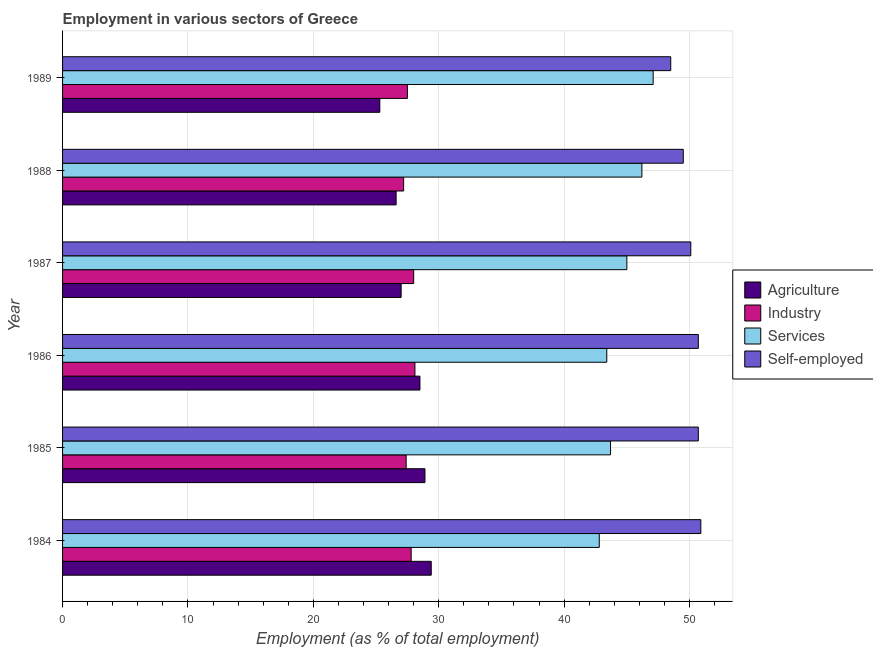How many different coloured bars are there?
Provide a succinct answer. 4. How many groups of bars are there?
Your response must be concise. 6. Are the number of bars per tick equal to the number of legend labels?
Offer a very short reply. Yes. Are the number of bars on each tick of the Y-axis equal?
Your answer should be compact. Yes. How many bars are there on the 6th tick from the top?
Offer a terse response. 4. How many bars are there on the 6th tick from the bottom?
Ensure brevity in your answer.  4. In how many cases, is the number of bars for a given year not equal to the number of legend labels?
Make the answer very short. 0. What is the percentage of workers in services in 1989?
Keep it short and to the point. 47.1. Across all years, what is the maximum percentage of workers in industry?
Make the answer very short. 28.1. Across all years, what is the minimum percentage of workers in agriculture?
Ensure brevity in your answer.  25.3. In which year was the percentage of workers in industry maximum?
Offer a terse response. 1986. In which year was the percentage of workers in industry minimum?
Ensure brevity in your answer.  1988. What is the total percentage of self employed workers in the graph?
Give a very brief answer. 300.4. What is the difference between the percentage of workers in industry in 1984 and that in 1986?
Give a very brief answer. -0.3. What is the difference between the percentage of workers in agriculture in 1988 and the percentage of self employed workers in 1984?
Ensure brevity in your answer.  -24.3. What is the average percentage of workers in services per year?
Provide a short and direct response. 44.7. In the year 1987, what is the difference between the percentage of workers in agriculture and percentage of self employed workers?
Your answer should be compact. -23.1. In how many years, is the percentage of workers in agriculture greater than 34 %?
Give a very brief answer. 0. Is the percentage of self employed workers in 1984 less than that in 1987?
Make the answer very short. No. Is the difference between the percentage of self employed workers in 1985 and 1986 greater than the difference between the percentage of workers in industry in 1985 and 1986?
Your answer should be compact. Yes. What is the difference between the highest and the second highest percentage of workers in industry?
Make the answer very short. 0.1. Is it the case that in every year, the sum of the percentage of workers in industry and percentage of self employed workers is greater than the sum of percentage of workers in services and percentage of workers in agriculture?
Your response must be concise. Yes. What does the 1st bar from the top in 1989 represents?
Offer a very short reply. Self-employed. What does the 1st bar from the bottom in 1984 represents?
Offer a terse response. Agriculture. Is it the case that in every year, the sum of the percentage of workers in agriculture and percentage of workers in industry is greater than the percentage of workers in services?
Provide a short and direct response. Yes. How many bars are there?
Your answer should be compact. 24. Are all the bars in the graph horizontal?
Offer a terse response. Yes. What is the difference between two consecutive major ticks on the X-axis?
Make the answer very short. 10. Are the values on the major ticks of X-axis written in scientific E-notation?
Your answer should be compact. No. Does the graph contain any zero values?
Make the answer very short. No. How many legend labels are there?
Offer a terse response. 4. How are the legend labels stacked?
Keep it short and to the point. Vertical. What is the title of the graph?
Keep it short and to the point. Employment in various sectors of Greece. Does "Trade" appear as one of the legend labels in the graph?
Your answer should be very brief. No. What is the label or title of the X-axis?
Make the answer very short. Employment (as % of total employment). What is the label or title of the Y-axis?
Your answer should be compact. Year. What is the Employment (as % of total employment) of Agriculture in 1984?
Give a very brief answer. 29.4. What is the Employment (as % of total employment) of Industry in 1984?
Make the answer very short. 27.8. What is the Employment (as % of total employment) of Services in 1984?
Offer a very short reply. 42.8. What is the Employment (as % of total employment) of Self-employed in 1984?
Give a very brief answer. 50.9. What is the Employment (as % of total employment) of Agriculture in 1985?
Ensure brevity in your answer.  28.9. What is the Employment (as % of total employment) in Industry in 1985?
Ensure brevity in your answer.  27.4. What is the Employment (as % of total employment) of Services in 1985?
Your response must be concise. 43.7. What is the Employment (as % of total employment) of Self-employed in 1985?
Offer a very short reply. 50.7. What is the Employment (as % of total employment) in Industry in 1986?
Make the answer very short. 28.1. What is the Employment (as % of total employment) in Services in 1986?
Offer a terse response. 43.4. What is the Employment (as % of total employment) of Self-employed in 1986?
Your answer should be compact. 50.7. What is the Employment (as % of total employment) in Agriculture in 1987?
Your answer should be very brief. 27. What is the Employment (as % of total employment) in Services in 1987?
Provide a short and direct response. 45. What is the Employment (as % of total employment) of Self-employed in 1987?
Your answer should be compact. 50.1. What is the Employment (as % of total employment) of Agriculture in 1988?
Provide a short and direct response. 26.6. What is the Employment (as % of total employment) of Industry in 1988?
Offer a terse response. 27.2. What is the Employment (as % of total employment) of Services in 1988?
Give a very brief answer. 46.2. What is the Employment (as % of total employment) of Self-employed in 1988?
Offer a terse response. 49.5. What is the Employment (as % of total employment) of Agriculture in 1989?
Offer a very short reply. 25.3. What is the Employment (as % of total employment) in Industry in 1989?
Your answer should be compact. 27.5. What is the Employment (as % of total employment) in Services in 1989?
Ensure brevity in your answer.  47.1. What is the Employment (as % of total employment) in Self-employed in 1989?
Offer a terse response. 48.5. Across all years, what is the maximum Employment (as % of total employment) in Agriculture?
Provide a succinct answer. 29.4. Across all years, what is the maximum Employment (as % of total employment) in Industry?
Provide a succinct answer. 28.1. Across all years, what is the maximum Employment (as % of total employment) in Services?
Keep it short and to the point. 47.1. Across all years, what is the maximum Employment (as % of total employment) in Self-employed?
Keep it short and to the point. 50.9. Across all years, what is the minimum Employment (as % of total employment) in Agriculture?
Your answer should be very brief. 25.3. Across all years, what is the minimum Employment (as % of total employment) of Industry?
Your response must be concise. 27.2. Across all years, what is the minimum Employment (as % of total employment) of Services?
Keep it short and to the point. 42.8. Across all years, what is the minimum Employment (as % of total employment) in Self-employed?
Your answer should be compact. 48.5. What is the total Employment (as % of total employment) of Agriculture in the graph?
Make the answer very short. 165.7. What is the total Employment (as % of total employment) in Industry in the graph?
Offer a terse response. 166. What is the total Employment (as % of total employment) of Services in the graph?
Offer a very short reply. 268.2. What is the total Employment (as % of total employment) in Self-employed in the graph?
Your answer should be very brief. 300.4. What is the difference between the Employment (as % of total employment) in Self-employed in 1984 and that in 1985?
Make the answer very short. 0.2. What is the difference between the Employment (as % of total employment) of Agriculture in 1984 and that in 1986?
Your response must be concise. 0.9. What is the difference between the Employment (as % of total employment) of Industry in 1984 and that in 1986?
Keep it short and to the point. -0.3. What is the difference between the Employment (as % of total employment) of Self-employed in 1984 and that in 1987?
Offer a terse response. 0.8. What is the difference between the Employment (as % of total employment) of Industry in 1984 and that in 1988?
Offer a very short reply. 0.6. What is the difference between the Employment (as % of total employment) of Services in 1984 and that in 1988?
Make the answer very short. -3.4. What is the difference between the Employment (as % of total employment) of Industry in 1984 and that in 1989?
Your answer should be compact. 0.3. What is the difference between the Employment (as % of total employment) of Self-employed in 1984 and that in 1989?
Offer a very short reply. 2.4. What is the difference between the Employment (as % of total employment) of Agriculture in 1985 and that in 1986?
Offer a very short reply. 0.4. What is the difference between the Employment (as % of total employment) in Services in 1985 and that in 1986?
Ensure brevity in your answer.  0.3. What is the difference between the Employment (as % of total employment) in Self-employed in 1985 and that in 1986?
Your answer should be compact. 0. What is the difference between the Employment (as % of total employment) of Industry in 1985 and that in 1987?
Give a very brief answer. -0.6. What is the difference between the Employment (as % of total employment) of Self-employed in 1985 and that in 1987?
Give a very brief answer. 0.6. What is the difference between the Employment (as % of total employment) in Agriculture in 1985 and that in 1989?
Make the answer very short. 3.6. What is the difference between the Employment (as % of total employment) in Services in 1985 and that in 1989?
Offer a terse response. -3.4. What is the difference between the Employment (as % of total employment) of Self-employed in 1985 and that in 1989?
Give a very brief answer. 2.2. What is the difference between the Employment (as % of total employment) in Agriculture in 1986 and that in 1987?
Offer a very short reply. 1.5. What is the difference between the Employment (as % of total employment) of Industry in 1986 and that in 1987?
Offer a very short reply. 0.1. What is the difference between the Employment (as % of total employment) in Services in 1986 and that in 1987?
Provide a short and direct response. -1.6. What is the difference between the Employment (as % of total employment) in Self-employed in 1986 and that in 1987?
Offer a very short reply. 0.6. What is the difference between the Employment (as % of total employment) of Agriculture in 1986 and that in 1988?
Offer a terse response. 1.9. What is the difference between the Employment (as % of total employment) in Self-employed in 1986 and that in 1988?
Ensure brevity in your answer.  1.2. What is the difference between the Employment (as % of total employment) of Agriculture in 1986 and that in 1989?
Your answer should be very brief. 3.2. What is the difference between the Employment (as % of total employment) in Industry in 1986 and that in 1989?
Offer a terse response. 0.6. What is the difference between the Employment (as % of total employment) in Services in 1986 and that in 1989?
Give a very brief answer. -3.7. What is the difference between the Employment (as % of total employment) of Self-employed in 1986 and that in 1989?
Provide a short and direct response. 2.2. What is the difference between the Employment (as % of total employment) in Agriculture in 1987 and that in 1988?
Your answer should be very brief. 0.4. What is the difference between the Employment (as % of total employment) in Self-employed in 1987 and that in 1988?
Give a very brief answer. 0.6. What is the difference between the Employment (as % of total employment) in Industry in 1988 and that in 1989?
Make the answer very short. -0.3. What is the difference between the Employment (as % of total employment) of Agriculture in 1984 and the Employment (as % of total employment) of Industry in 1985?
Make the answer very short. 2. What is the difference between the Employment (as % of total employment) of Agriculture in 1984 and the Employment (as % of total employment) of Services in 1985?
Provide a succinct answer. -14.3. What is the difference between the Employment (as % of total employment) in Agriculture in 1984 and the Employment (as % of total employment) in Self-employed in 1985?
Your answer should be very brief. -21.3. What is the difference between the Employment (as % of total employment) in Industry in 1984 and the Employment (as % of total employment) in Services in 1985?
Your answer should be very brief. -15.9. What is the difference between the Employment (as % of total employment) in Industry in 1984 and the Employment (as % of total employment) in Self-employed in 1985?
Make the answer very short. -22.9. What is the difference between the Employment (as % of total employment) in Services in 1984 and the Employment (as % of total employment) in Self-employed in 1985?
Give a very brief answer. -7.9. What is the difference between the Employment (as % of total employment) of Agriculture in 1984 and the Employment (as % of total employment) of Services in 1986?
Your answer should be very brief. -14. What is the difference between the Employment (as % of total employment) of Agriculture in 1984 and the Employment (as % of total employment) of Self-employed in 1986?
Give a very brief answer. -21.3. What is the difference between the Employment (as % of total employment) of Industry in 1984 and the Employment (as % of total employment) of Services in 1986?
Your answer should be very brief. -15.6. What is the difference between the Employment (as % of total employment) in Industry in 1984 and the Employment (as % of total employment) in Self-employed in 1986?
Give a very brief answer. -22.9. What is the difference between the Employment (as % of total employment) of Agriculture in 1984 and the Employment (as % of total employment) of Services in 1987?
Give a very brief answer. -15.6. What is the difference between the Employment (as % of total employment) in Agriculture in 1984 and the Employment (as % of total employment) in Self-employed in 1987?
Make the answer very short. -20.7. What is the difference between the Employment (as % of total employment) in Industry in 1984 and the Employment (as % of total employment) in Services in 1987?
Give a very brief answer. -17.2. What is the difference between the Employment (as % of total employment) in Industry in 1984 and the Employment (as % of total employment) in Self-employed in 1987?
Your answer should be compact. -22.3. What is the difference between the Employment (as % of total employment) of Agriculture in 1984 and the Employment (as % of total employment) of Industry in 1988?
Your answer should be compact. 2.2. What is the difference between the Employment (as % of total employment) in Agriculture in 1984 and the Employment (as % of total employment) in Services in 1988?
Offer a very short reply. -16.8. What is the difference between the Employment (as % of total employment) in Agriculture in 1984 and the Employment (as % of total employment) in Self-employed in 1988?
Your answer should be compact. -20.1. What is the difference between the Employment (as % of total employment) in Industry in 1984 and the Employment (as % of total employment) in Services in 1988?
Give a very brief answer. -18.4. What is the difference between the Employment (as % of total employment) of Industry in 1984 and the Employment (as % of total employment) of Self-employed in 1988?
Your response must be concise. -21.7. What is the difference between the Employment (as % of total employment) of Agriculture in 1984 and the Employment (as % of total employment) of Industry in 1989?
Provide a succinct answer. 1.9. What is the difference between the Employment (as % of total employment) in Agriculture in 1984 and the Employment (as % of total employment) in Services in 1989?
Make the answer very short. -17.7. What is the difference between the Employment (as % of total employment) of Agriculture in 1984 and the Employment (as % of total employment) of Self-employed in 1989?
Your answer should be very brief. -19.1. What is the difference between the Employment (as % of total employment) in Industry in 1984 and the Employment (as % of total employment) in Services in 1989?
Give a very brief answer. -19.3. What is the difference between the Employment (as % of total employment) in Industry in 1984 and the Employment (as % of total employment) in Self-employed in 1989?
Your answer should be very brief. -20.7. What is the difference between the Employment (as % of total employment) of Services in 1984 and the Employment (as % of total employment) of Self-employed in 1989?
Make the answer very short. -5.7. What is the difference between the Employment (as % of total employment) of Agriculture in 1985 and the Employment (as % of total employment) of Self-employed in 1986?
Your answer should be very brief. -21.8. What is the difference between the Employment (as % of total employment) of Industry in 1985 and the Employment (as % of total employment) of Services in 1986?
Give a very brief answer. -16. What is the difference between the Employment (as % of total employment) in Industry in 1985 and the Employment (as % of total employment) in Self-employed in 1986?
Ensure brevity in your answer.  -23.3. What is the difference between the Employment (as % of total employment) of Services in 1985 and the Employment (as % of total employment) of Self-employed in 1986?
Offer a very short reply. -7. What is the difference between the Employment (as % of total employment) of Agriculture in 1985 and the Employment (as % of total employment) of Industry in 1987?
Offer a very short reply. 0.9. What is the difference between the Employment (as % of total employment) of Agriculture in 1985 and the Employment (as % of total employment) of Services in 1987?
Provide a short and direct response. -16.1. What is the difference between the Employment (as % of total employment) of Agriculture in 1985 and the Employment (as % of total employment) of Self-employed in 1987?
Make the answer very short. -21.2. What is the difference between the Employment (as % of total employment) in Industry in 1985 and the Employment (as % of total employment) in Services in 1987?
Make the answer very short. -17.6. What is the difference between the Employment (as % of total employment) of Industry in 1985 and the Employment (as % of total employment) of Self-employed in 1987?
Give a very brief answer. -22.7. What is the difference between the Employment (as % of total employment) in Services in 1985 and the Employment (as % of total employment) in Self-employed in 1987?
Offer a very short reply. -6.4. What is the difference between the Employment (as % of total employment) of Agriculture in 1985 and the Employment (as % of total employment) of Services in 1988?
Ensure brevity in your answer.  -17.3. What is the difference between the Employment (as % of total employment) of Agriculture in 1985 and the Employment (as % of total employment) of Self-employed in 1988?
Your response must be concise. -20.6. What is the difference between the Employment (as % of total employment) of Industry in 1985 and the Employment (as % of total employment) of Services in 1988?
Your answer should be very brief. -18.8. What is the difference between the Employment (as % of total employment) of Industry in 1985 and the Employment (as % of total employment) of Self-employed in 1988?
Provide a short and direct response. -22.1. What is the difference between the Employment (as % of total employment) of Agriculture in 1985 and the Employment (as % of total employment) of Services in 1989?
Provide a short and direct response. -18.2. What is the difference between the Employment (as % of total employment) of Agriculture in 1985 and the Employment (as % of total employment) of Self-employed in 1989?
Keep it short and to the point. -19.6. What is the difference between the Employment (as % of total employment) of Industry in 1985 and the Employment (as % of total employment) of Services in 1989?
Provide a short and direct response. -19.7. What is the difference between the Employment (as % of total employment) of Industry in 1985 and the Employment (as % of total employment) of Self-employed in 1989?
Offer a terse response. -21.1. What is the difference between the Employment (as % of total employment) of Services in 1985 and the Employment (as % of total employment) of Self-employed in 1989?
Your answer should be compact. -4.8. What is the difference between the Employment (as % of total employment) of Agriculture in 1986 and the Employment (as % of total employment) of Industry in 1987?
Your answer should be very brief. 0.5. What is the difference between the Employment (as % of total employment) in Agriculture in 1986 and the Employment (as % of total employment) in Services in 1987?
Your response must be concise. -16.5. What is the difference between the Employment (as % of total employment) of Agriculture in 1986 and the Employment (as % of total employment) of Self-employed in 1987?
Ensure brevity in your answer.  -21.6. What is the difference between the Employment (as % of total employment) of Industry in 1986 and the Employment (as % of total employment) of Services in 1987?
Offer a very short reply. -16.9. What is the difference between the Employment (as % of total employment) of Services in 1986 and the Employment (as % of total employment) of Self-employed in 1987?
Make the answer very short. -6.7. What is the difference between the Employment (as % of total employment) in Agriculture in 1986 and the Employment (as % of total employment) in Industry in 1988?
Your response must be concise. 1.3. What is the difference between the Employment (as % of total employment) of Agriculture in 1986 and the Employment (as % of total employment) of Services in 1988?
Your answer should be compact. -17.7. What is the difference between the Employment (as % of total employment) of Industry in 1986 and the Employment (as % of total employment) of Services in 1988?
Offer a terse response. -18.1. What is the difference between the Employment (as % of total employment) of Industry in 1986 and the Employment (as % of total employment) of Self-employed in 1988?
Keep it short and to the point. -21.4. What is the difference between the Employment (as % of total employment) of Services in 1986 and the Employment (as % of total employment) of Self-employed in 1988?
Make the answer very short. -6.1. What is the difference between the Employment (as % of total employment) in Agriculture in 1986 and the Employment (as % of total employment) in Services in 1989?
Your answer should be very brief. -18.6. What is the difference between the Employment (as % of total employment) in Agriculture in 1986 and the Employment (as % of total employment) in Self-employed in 1989?
Offer a very short reply. -20. What is the difference between the Employment (as % of total employment) of Industry in 1986 and the Employment (as % of total employment) of Self-employed in 1989?
Keep it short and to the point. -20.4. What is the difference between the Employment (as % of total employment) of Services in 1986 and the Employment (as % of total employment) of Self-employed in 1989?
Offer a very short reply. -5.1. What is the difference between the Employment (as % of total employment) in Agriculture in 1987 and the Employment (as % of total employment) in Industry in 1988?
Make the answer very short. -0.2. What is the difference between the Employment (as % of total employment) of Agriculture in 1987 and the Employment (as % of total employment) of Services in 1988?
Offer a very short reply. -19.2. What is the difference between the Employment (as % of total employment) in Agriculture in 1987 and the Employment (as % of total employment) in Self-employed in 1988?
Provide a short and direct response. -22.5. What is the difference between the Employment (as % of total employment) of Industry in 1987 and the Employment (as % of total employment) of Services in 1988?
Ensure brevity in your answer.  -18.2. What is the difference between the Employment (as % of total employment) of Industry in 1987 and the Employment (as % of total employment) of Self-employed in 1988?
Provide a succinct answer. -21.5. What is the difference between the Employment (as % of total employment) of Agriculture in 1987 and the Employment (as % of total employment) of Services in 1989?
Keep it short and to the point. -20.1. What is the difference between the Employment (as % of total employment) of Agriculture in 1987 and the Employment (as % of total employment) of Self-employed in 1989?
Offer a terse response. -21.5. What is the difference between the Employment (as % of total employment) of Industry in 1987 and the Employment (as % of total employment) of Services in 1989?
Your answer should be very brief. -19.1. What is the difference between the Employment (as % of total employment) of Industry in 1987 and the Employment (as % of total employment) of Self-employed in 1989?
Offer a very short reply. -20.5. What is the difference between the Employment (as % of total employment) of Services in 1987 and the Employment (as % of total employment) of Self-employed in 1989?
Keep it short and to the point. -3.5. What is the difference between the Employment (as % of total employment) in Agriculture in 1988 and the Employment (as % of total employment) in Industry in 1989?
Offer a terse response. -0.9. What is the difference between the Employment (as % of total employment) in Agriculture in 1988 and the Employment (as % of total employment) in Services in 1989?
Give a very brief answer. -20.5. What is the difference between the Employment (as % of total employment) of Agriculture in 1988 and the Employment (as % of total employment) of Self-employed in 1989?
Offer a terse response. -21.9. What is the difference between the Employment (as % of total employment) of Industry in 1988 and the Employment (as % of total employment) of Services in 1989?
Provide a short and direct response. -19.9. What is the difference between the Employment (as % of total employment) in Industry in 1988 and the Employment (as % of total employment) in Self-employed in 1989?
Your response must be concise. -21.3. What is the average Employment (as % of total employment) in Agriculture per year?
Give a very brief answer. 27.62. What is the average Employment (as % of total employment) of Industry per year?
Offer a terse response. 27.67. What is the average Employment (as % of total employment) of Services per year?
Your answer should be very brief. 44.7. What is the average Employment (as % of total employment) in Self-employed per year?
Keep it short and to the point. 50.07. In the year 1984, what is the difference between the Employment (as % of total employment) in Agriculture and Employment (as % of total employment) in Industry?
Provide a succinct answer. 1.6. In the year 1984, what is the difference between the Employment (as % of total employment) of Agriculture and Employment (as % of total employment) of Self-employed?
Offer a terse response. -21.5. In the year 1984, what is the difference between the Employment (as % of total employment) of Industry and Employment (as % of total employment) of Self-employed?
Make the answer very short. -23.1. In the year 1984, what is the difference between the Employment (as % of total employment) in Services and Employment (as % of total employment) in Self-employed?
Ensure brevity in your answer.  -8.1. In the year 1985, what is the difference between the Employment (as % of total employment) in Agriculture and Employment (as % of total employment) in Services?
Your response must be concise. -14.8. In the year 1985, what is the difference between the Employment (as % of total employment) in Agriculture and Employment (as % of total employment) in Self-employed?
Provide a short and direct response. -21.8. In the year 1985, what is the difference between the Employment (as % of total employment) in Industry and Employment (as % of total employment) in Services?
Your answer should be compact. -16.3. In the year 1985, what is the difference between the Employment (as % of total employment) in Industry and Employment (as % of total employment) in Self-employed?
Your answer should be very brief. -23.3. In the year 1985, what is the difference between the Employment (as % of total employment) in Services and Employment (as % of total employment) in Self-employed?
Your answer should be compact. -7. In the year 1986, what is the difference between the Employment (as % of total employment) in Agriculture and Employment (as % of total employment) in Industry?
Provide a succinct answer. 0.4. In the year 1986, what is the difference between the Employment (as % of total employment) of Agriculture and Employment (as % of total employment) of Services?
Give a very brief answer. -14.9. In the year 1986, what is the difference between the Employment (as % of total employment) of Agriculture and Employment (as % of total employment) of Self-employed?
Offer a terse response. -22.2. In the year 1986, what is the difference between the Employment (as % of total employment) in Industry and Employment (as % of total employment) in Services?
Offer a very short reply. -15.3. In the year 1986, what is the difference between the Employment (as % of total employment) of Industry and Employment (as % of total employment) of Self-employed?
Your answer should be very brief. -22.6. In the year 1987, what is the difference between the Employment (as % of total employment) in Agriculture and Employment (as % of total employment) in Services?
Keep it short and to the point. -18. In the year 1987, what is the difference between the Employment (as % of total employment) in Agriculture and Employment (as % of total employment) in Self-employed?
Offer a terse response. -23.1. In the year 1987, what is the difference between the Employment (as % of total employment) of Industry and Employment (as % of total employment) of Self-employed?
Ensure brevity in your answer.  -22.1. In the year 1988, what is the difference between the Employment (as % of total employment) of Agriculture and Employment (as % of total employment) of Services?
Offer a terse response. -19.6. In the year 1988, what is the difference between the Employment (as % of total employment) of Agriculture and Employment (as % of total employment) of Self-employed?
Give a very brief answer. -22.9. In the year 1988, what is the difference between the Employment (as % of total employment) in Industry and Employment (as % of total employment) in Services?
Provide a short and direct response. -19. In the year 1988, what is the difference between the Employment (as % of total employment) in Industry and Employment (as % of total employment) in Self-employed?
Make the answer very short. -22.3. In the year 1988, what is the difference between the Employment (as % of total employment) of Services and Employment (as % of total employment) of Self-employed?
Make the answer very short. -3.3. In the year 1989, what is the difference between the Employment (as % of total employment) of Agriculture and Employment (as % of total employment) of Industry?
Give a very brief answer. -2.2. In the year 1989, what is the difference between the Employment (as % of total employment) in Agriculture and Employment (as % of total employment) in Services?
Your answer should be very brief. -21.8. In the year 1989, what is the difference between the Employment (as % of total employment) in Agriculture and Employment (as % of total employment) in Self-employed?
Ensure brevity in your answer.  -23.2. In the year 1989, what is the difference between the Employment (as % of total employment) in Industry and Employment (as % of total employment) in Services?
Your response must be concise. -19.6. In the year 1989, what is the difference between the Employment (as % of total employment) of Services and Employment (as % of total employment) of Self-employed?
Provide a succinct answer. -1.4. What is the ratio of the Employment (as % of total employment) of Agriculture in 1984 to that in 1985?
Your answer should be very brief. 1.02. What is the ratio of the Employment (as % of total employment) in Industry in 1984 to that in 1985?
Give a very brief answer. 1.01. What is the ratio of the Employment (as % of total employment) in Services in 1984 to that in 1985?
Offer a very short reply. 0.98. What is the ratio of the Employment (as % of total employment) in Self-employed in 1984 to that in 1985?
Provide a short and direct response. 1. What is the ratio of the Employment (as % of total employment) of Agriculture in 1984 to that in 1986?
Make the answer very short. 1.03. What is the ratio of the Employment (as % of total employment) of Industry in 1984 to that in 1986?
Ensure brevity in your answer.  0.99. What is the ratio of the Employment (as % of total employment) of Services in 1984 to that in 1986?
Provide a succinct answer. 0.99. What is the ratio of the Employment (as % of total employment) of Self-employed in 1984 to that in 1986?
Provide a short and direct response. 1. What is the ratio of the Employment (as % of total employment) of Agriculture in 1984 to that in 1987?
Offer a terse response. 1.09. What is the ratio of the Employment (as % of total employment) in Industry in 1984 to that in 1987?
Offer a very short reply. 0.99. What is the ratio of the Employment (as % of total employment) of Services in 1984 to that in 1987?
Provide a succinct answer. 0.95. What is the ratio of the Employment (as % of total employment) of Agriculture in 1984 to that in 1988?
Offer a terse response. 1.11. What is the ratio of the Employment (as % of total employment) in Industry in 1984 to that in 1988?
Your response must be concise. 1.02. What is the ratio of the Employment (as % of total employment) in Services in 1984 to that in 1988?
Offer a very short reply. 0.93. What is the ratio of the Employment (as % of total employment) in Self-employed in 1984 to that in 1988?
Your answer should be compact. 1.03. What is the ratio of the Employment (as % of total employment) in Agriculture in 1984 to that in 1989?
Offer a terse response. 1.16. What is the ratio of the Employment (as % of total employment) in Industry in 1984 to that in 1989?
Provide a succinct answer. 1.01. What is the ratio of the Employment (as % of total employment) in Services in 1984 to that in 1989?
Offer a very short reply. 0.91. What is the ratio of the Employment (as % of total employment) in Self-employed in 1984 to that in 1989?
Offer a very short reply. 1.05. What is the ratio of the Employment (as % of total employment) of Industry in 1985 to that in 1986?
Your response must be concise. 0.98. What is the ratio of the Employment (as % of total employment) in Self-employed in 1985 to that in 1986?
Keep it short and to the point. 1. What is the ratio of the Employment (as % of total employment) in Agriculture in 1985 to that in 1987?
Make the answer very short. 1.07. What is the ratio of the Employment (as % of total employment) in Industry in 1985 to that in 1987?
Your response must be concise. 0.98. What is the ratio of the Employment (as % of total employment) in Services in 1985 to that in 1987?
Offer a terse response. 0.97. What is the ratio of the Employment (as % of total employment) in Agriculture in 1985 to that in 1988?
Keep it short and to the point. 1.09. What is the ratio of the Employment (as % of total employment) of Industry in 1985 to that in 1988?
Provide a short and direct response. 1.01. What is the ratio of the Employment (as % of total employment) in Services in 1985 to that in 1988?
Make the answer very short. 0.95. What is the ratio of the Employment (as % of total employment) in Self-employed in 1985 to that in 1988?
Your answer should be very brief. 1.02. What is the ratio of the Employment (as % of total employment) of Agriculture in 1985 to that in 1989?
Ensure brevity in your answer.  1.14. What is the ratio of the Employment (as % of total employment) of Industry in 1985 to that in 1989?
Provide a short and direct response. 1. What is the ratio of the Employment (as % of total employment) of Services in 1985 to that in 1989?
Your answer should be compact. 0.93. What is the ratio of the Employment (as % of total employment) in Self-employed in 1985 to that in 1989?
Provide a short and direct response. 1.05. What is the ratio of the Employment (as % of total employment) of Agriculture in 1986 to that in 1987?
Your answer should be compact. 1.06. What is the ratio of the Employment (as % of total employment) in Industry in 1986 to that in 1987?
Your answer should be compact. 1. What is the ratio of the Employment (as % of total employment) in Services in 1986 to that in 1987?
Provide a short and direct response. 0.96. What is the ratio of the Employment (as % of total employment) in Self-employed in 1986 to that in 1987?
Offer a very short reply. 1.01. What is the ratio of the Employment (as % of total employment) of Agriculture in 1986 to that in 1988?
Offer a terse response. 1.07. What is the ratio of the Employment (as % of total employment) of Industry in 1986 to that in 1988?
Provide a short and direct response. 1.03. What is the ratio of the Employment (as % of total employment) of Services in 1986 to that in 1988?
Your answer should be very brief. 0.94. What is the ratio of the Employment (as % of total employment) of Self-employed in 1986 to that in 1988?
Offer a very short reply. 1.02. What is the ratio of the Employment (as % of total employment) of Agriculture in 1986 to that in 1989?
Your answer should be very brief. 1.13. What is the ratio of the Employment (as % of total employment) of Industry in 1986 to that in 1989?
Provide a succinct answer. 1.02. What is the ratio of the Employment (as % of total employment) in Services in 1986 to that in 1989?
Ensure brevity in your answer.  0.92. What is the ratio of the Employment (as % of total employment) of Self-employed in 1986 to that in 1989?
Keep it short and to the point. 1.05. What is the ratio of the Employment (as % of total employment) in Industry in 1987 to that in 1988?
Provide a short and direct response. 1.03. What is the ratio of the Employment (as % of total employment) of Self-employed in 1987 to that in 1988?
Offer a terse response. 1.01. What is the ratio of the Employment (as % of total employment) in Agriculture in 1987 to that in 1989?
Keep it short and to the point. 1.07. What is the ratio of the Employment (as % of total employment) of Industry in 1987 to that in 1989?
Your answer should be compact. 1.02. What is the ratio of the Employment (as % of total employment) of Services in 1987 to that in 1989?
Give a very brief answer. 0.96. What is the ratio of the Employment (as % of total employment) of Self-employed in 1987 to that in 1989?
Provide a short and direct response. 1.03. What is the ratio of the Employment (as % of total employment) in Agriculture in 1988 to that in 1989?
Give a very brief answer. 1.05. What is the ratio of the Employment (as % of total employment) of Industry in 1988 to that in 1989?
Provide a succinct answer. 0.99. What is the ratio of the Employment (as % of total employment) of Services in 1988 to that in 1989?
Keep it short and to the point. 0.98. What is the ratio of the Employment (as % of total employment) in Self-employed in 1988 to that in 1989?
Your answer should be very brief. 1.02. What is the difference between the highest and the second highest Employment (as % of total employment) of Agriculture?
Your answer should be very brief. 0.5. What is the difference between the highest and the second highest Employment (as % of total employment) of Industry?
Offer a terse response. 0.1. What is the difference between the highest and the second highest Employment (as % of total employment) in Services?
Offer a terse response. 0.9. What is the difference between the highest and the lowest Employment (as % of total employment) of Agriculture?
Offer a terse response. 4.1. What is the difference between the highest and the lowest Employment (as % of total employment) of Industry?
Offer a terse response. 0.9. What is the difference between the highest and the lowest Employment (as % of total employment) in Self-employed?
Make the answer very short. 2.4. 